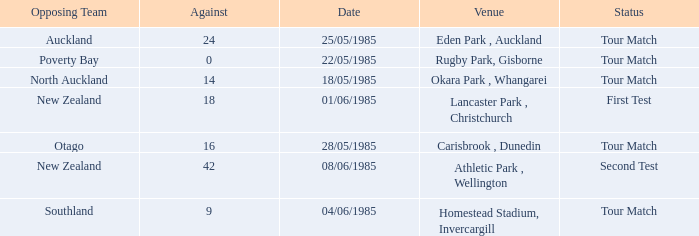What date was the opposing team Poverty Bay? 22/05/1985. 